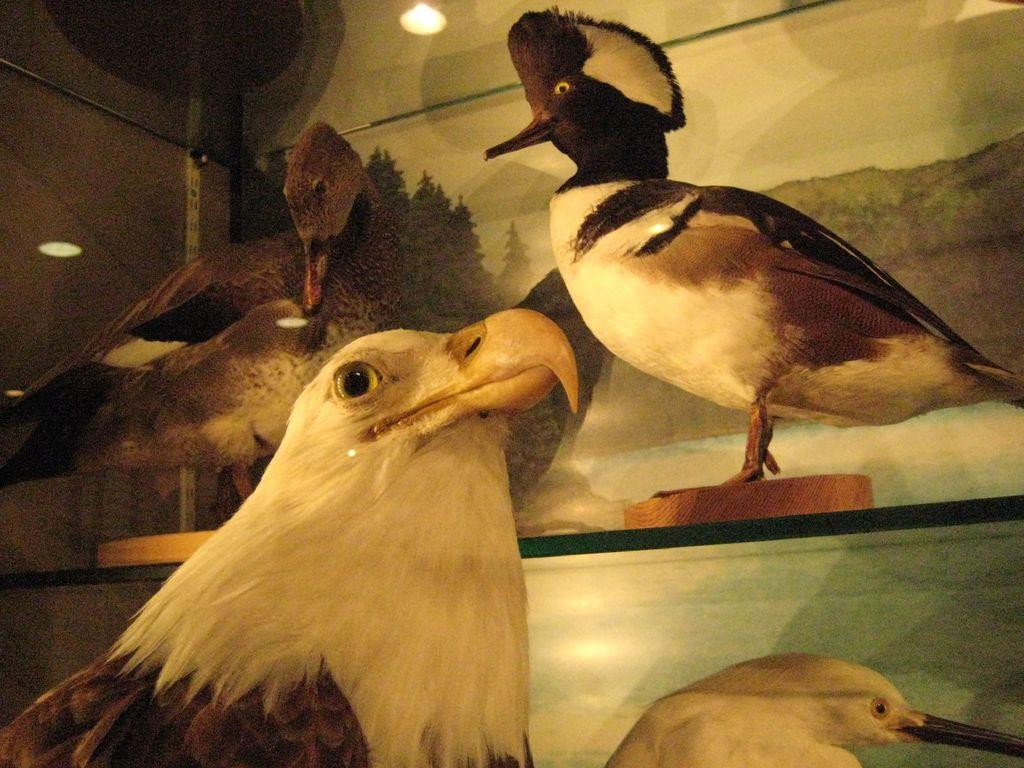What type of animals can be seen in the image? There are birds in the image. Where are the birds located? The birds are on shelves in the image. What can be seen behind the shelves in the image? There is a wall visible in the image. What provides illumination in the image? There is a light in the image. What type of houses are the birds building in the image? There are no houses present in the image, and the birds are not building anything. 